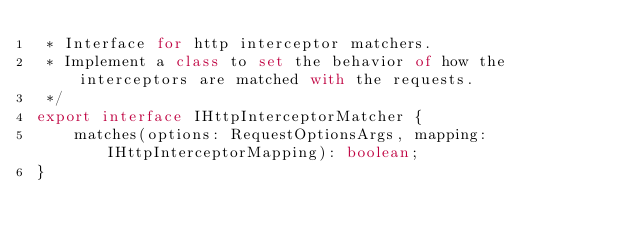Convert code to text. <code><loc_0><loc_0><loc_500><loc_500><_TypeScript_> * Interface for http interceptor matchers.
 * Implement a class to set the behavior of how the interceptors are matched with the requests.
 */
export interface IHttpInterceptorMatcher {
    matches(options: RequestOptionsArgs, mapping: IHttpInterceptorMapping): boolean;
}
</code> 